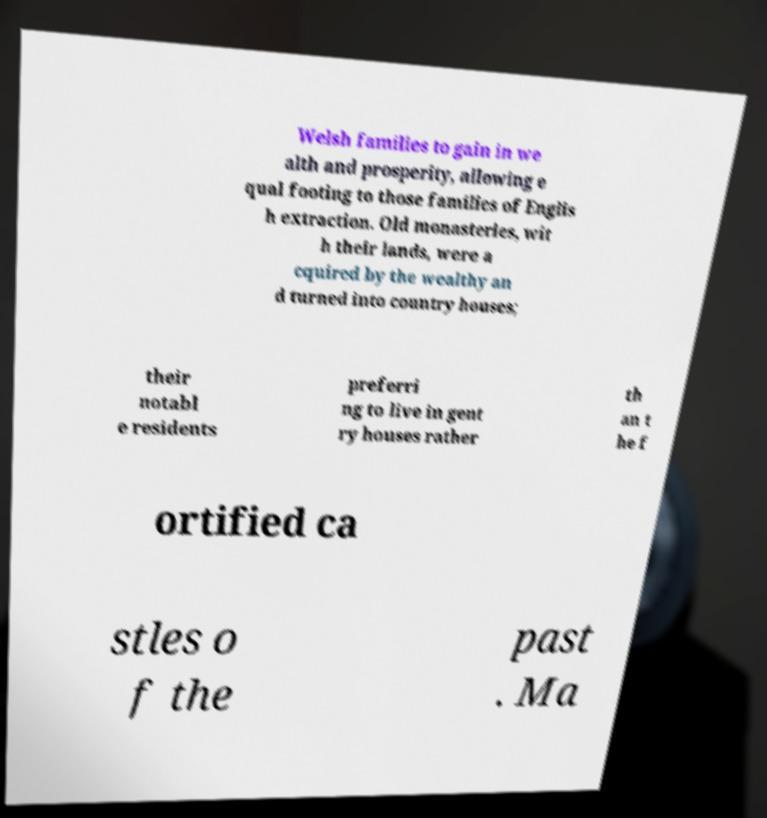For documentation purposes, I need the text within this image transcribed. Could you provide that? Welsh families to gain in we alth and prosperity, allowing e qual footing to those families of Englis h extraction. Old monasteries, wit h their lands, were a cquired by the wealthy an d turned into country houses; their notabl e residents preferri ng to live in gent ry houses rather th an t he f ortified ca stles o f the past . Ma 